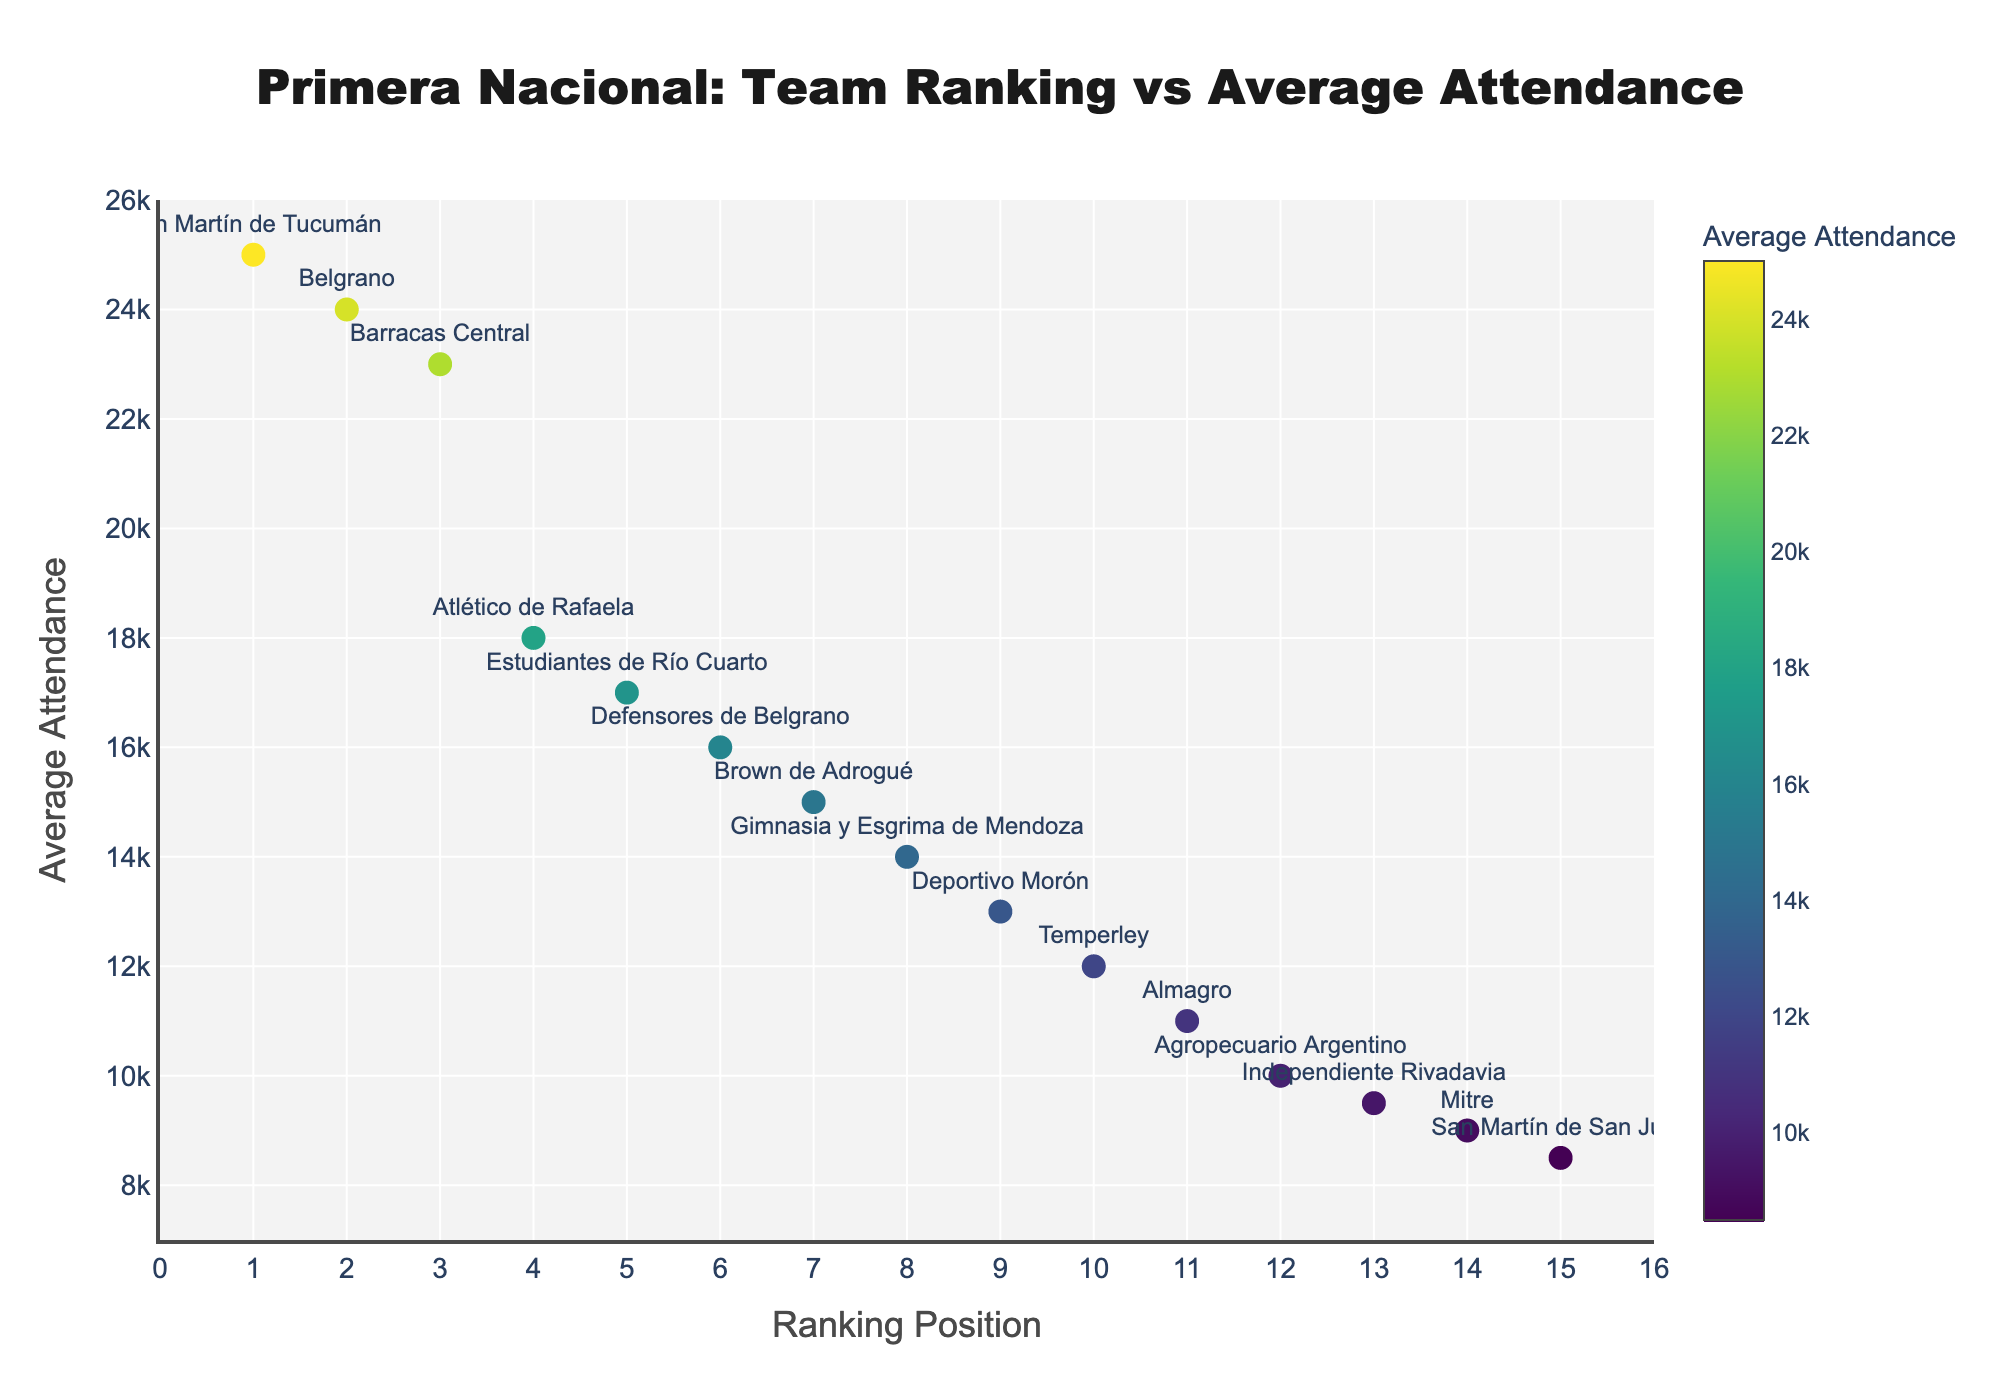How many teams are included in the scatter plot? There are 15 unique teams listed in the data provided. You can count the number of distinct points in the scatter plot to verify this.
Answer: 15 What team has the highest average attendance? By looking at the y-axis values, San Martín de Tucumán has the highest average attendance at 25,000.
Answer: San Martín de Tucumán Which team has a ranking position of 10 and what is its average attendance? Temperley is ranked 10th and has an average attendance of 12,000.
Answer: Temperley, 12,000 Which team has the lowest average attendance, and what is its ranking position? San Martín de San Juan has the lowest average attendance of 8,500, and its ranking position is 15.
Answer: San Martín de San Juan, 15 What is the average attendance for Belgrano? By referring to the y-axis and hover text, the average attendance for Belgrano is 24,000.
Answer: 24,000 What is the general trend in attendance as the ranking position increases? Observing the scatter plot, there is a general trend that attendance decreases as the ranking position increases. Higher-ranked teams have higher attendance.
Answer: Attendance generally decreases as ranking position increases What is the average attendance for teams ranked in the top 5 positions? San Martín de Tucumán (25,000), Belgrano (24,000), Barracas Central (23,000), Atlético de Rafaela (18,000), Estudiantes de Río Cuarto (17,000). The sum is 107,000, so the average is 107,000/5 = 21,400.
Answer: 21,400 Which team has a higher average attendance: Gimnasia y Esgrima de Mendoza or Deportivo Morón? Gimnasia y Esgrima de Mendoza has an average attendance of 14,000, while Deportivo Morón has 13,000. Therefore, Gimnasia y Esgrima de Mendoza has a higher average attendance.
Answer: Gimnasia y Esgrima de Mendoza How much higher is the average attendance of the highest team compared to the lowest team? The highest average attendance is 25,000 (San Martín de Tucumán) and the lowest is 8,500 (San Martín de San Juan). The difference is 25,000 - 8,500 = 16,500.
Answer: 16,500 